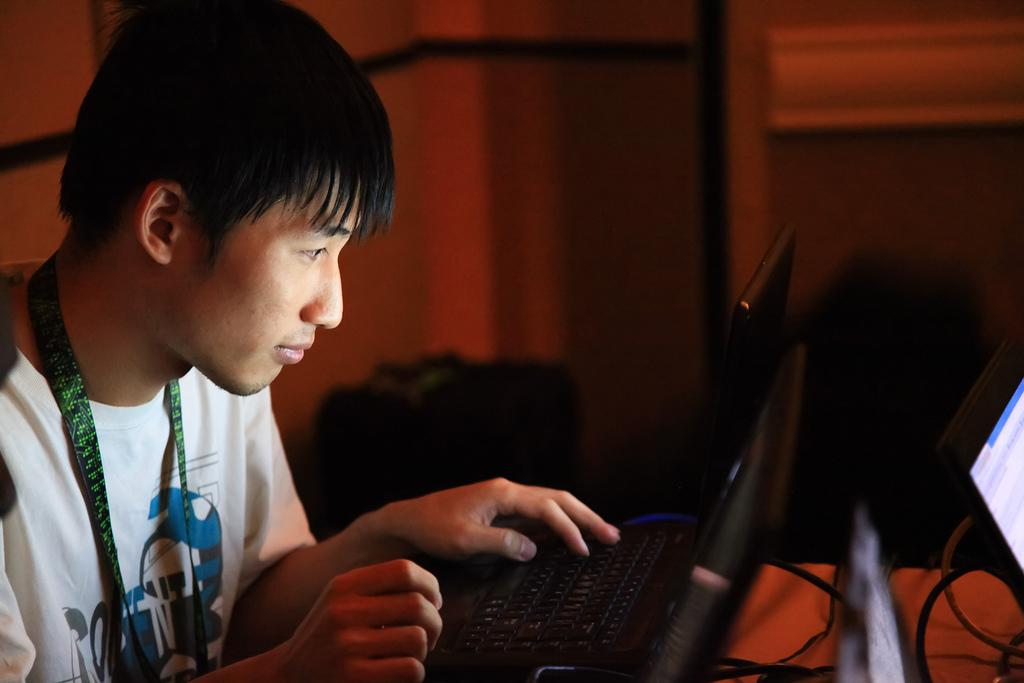What is the person in the image doing? The person in the image is operating a laptop. What color is the tag that the person is wearing? The person is wearing a green color tag. What color is the shirt that the person is wearing? The person is wearing a white color shirt. What type of ink is being used by the cat in the image? There is no cat present in the image, and therefore no ink or related activity can be observed. 